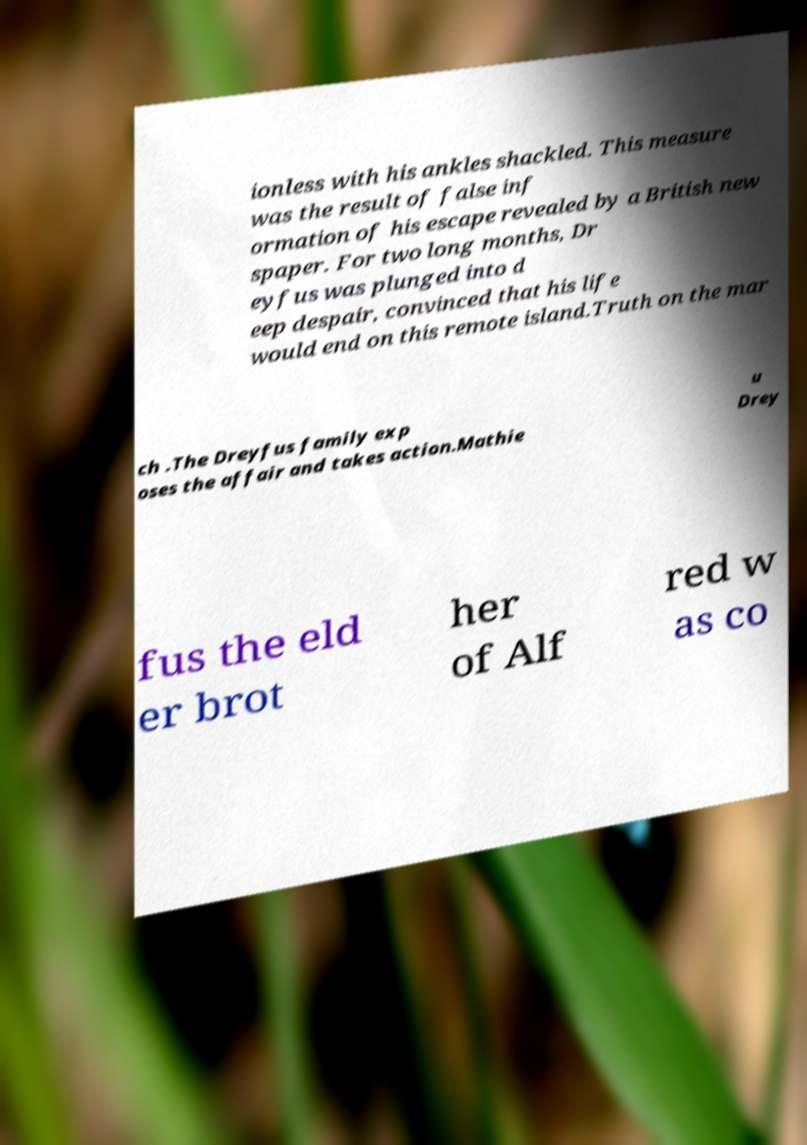For documentation purposes, I need the text within this image transcribed. Could you provide that? ionless with his ankles shackled. This measure was the result of false inf ormation of his escape revealed by a British new spaper. For two long months, Dr eyfus was plunged into d eep despair, convinced that his life would end on this remote island.Truth on the mar ch .The Dreyfus family exp oses the affair and takes action.Mathie u Drey fus the eld er brot her of Alf red w as co 